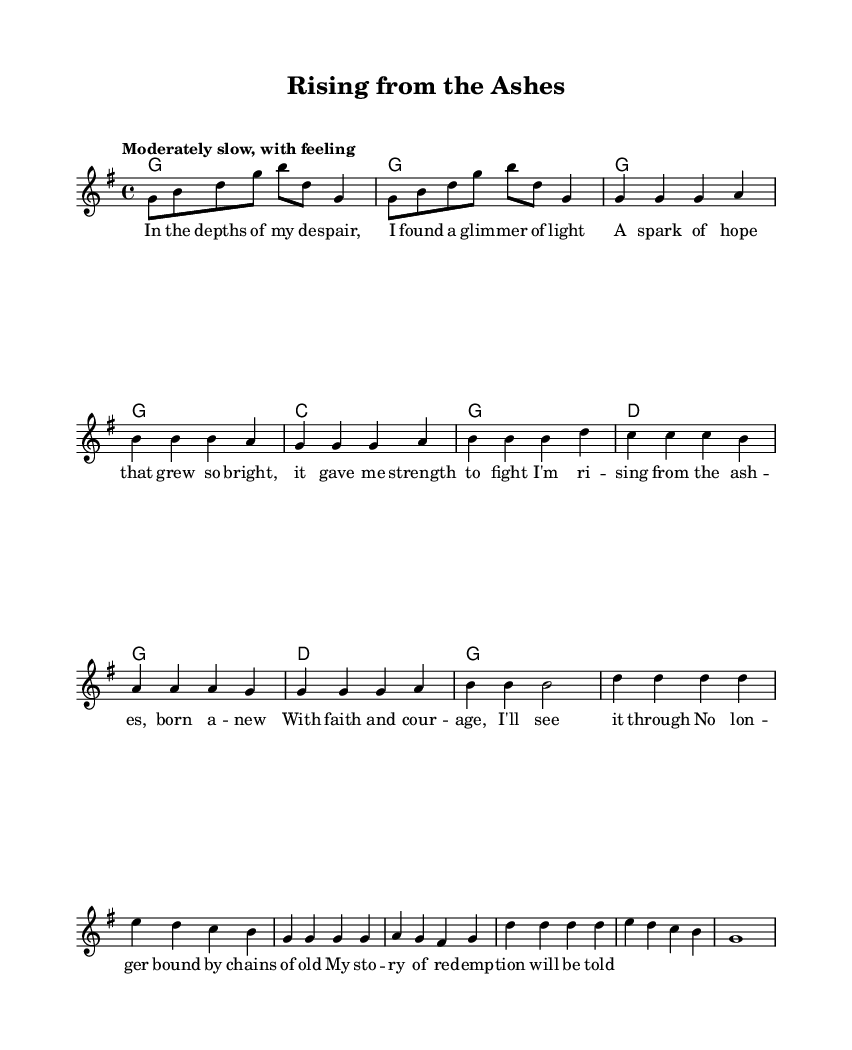What is the key signature of this music? The key signature shows one sharp, indicating that the piece is in G major. This is determined by checking the symbols at the beginning of the staff, which denote the keys.
Answer: G major What is the time signature of this piece? The time signature is marked as 4/4, which can be found at the beginning of the score. This means there are four beats in each measure, and a quarter note gets one beat.
Answer: 4/4 What is the tempo marking for the piece? The tempo marking is "Moderately slow, with feeling," which is typically indicated after the time signature and informs performers of the desired speed and emotional character of the music.
Answer: Moderately slow, with feeling How many measures are in the chorus? The chorus consists of six measures, which can be counted by examining the notation and looking for the vertical bar lines that indicate the end of each measure within that section.
Answer: Six What is the primary theme expressed in the lyrics of the chorus? The theme of the chorus revolves around personal transformation and hope. This is evident through the lyrics that discuss rising from despair and being reborn with faith and courage. This analysis can be drawn by interpreting the emotional content of the words.
Answer: Personal transformation and hope What is the first chord in the song? The first chord according to the harmonies in the score is G major, which is indicated at the beginning of the piece. This can be confirmed by looking at the chord symbols provided.
Answer: G major 